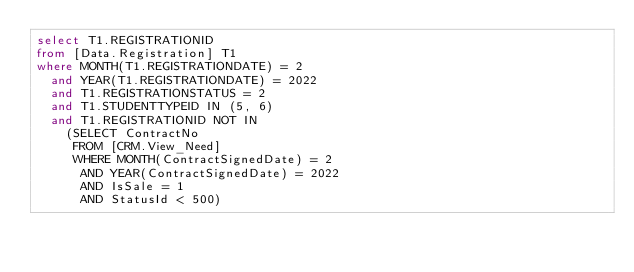Convert code to text. <code><loc_0><loc_0><loc_500><loc_500><_SQL_>select T1.REGISTRATIONID
from [Data.Registration] T1
where MONTH(T1.REGISTRATIONDATE) = 2
	and YEAR(T1.REGISTRATIONDATE) = 2022
	and T1.REGISTRATIONSTATUS = 2
	and T1.STUDENTTYPEID IN (5, 6)
	and T1.REGISTRATIONID NOT IN
		(SELECT ContractNo
		 FROM [CRM.View_Need]
		 WHERE MONTH(ContractSignedDate) = 2
			AND YEAR(ContractSignedDate) = 2022
			AND IsSale = 1
			AND StatusId < 500)</code> 